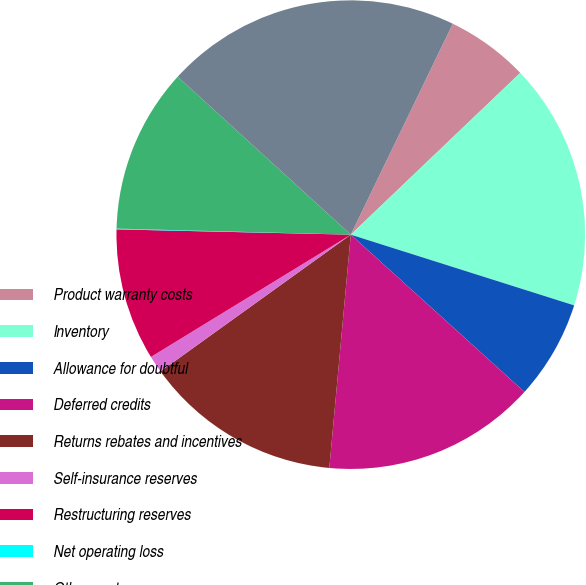<chart> <loc_0><loc_0><loc_500><loc_500><pie_chart><fcel>Product warranty costs<fcel>Inventory<fcel>Allowance for doubtful<fcel>Deferred credits<fcel>Returns rebates and incentives<fcel>Self-insurance reserves<fcel>Restructuring reserves<fcel>Net operating loss<fcel>Other - net<fcel>Current deferred income tax<nl><fcel>5.7%<fcel>17.01%<fcel>6.83%<fcel>14.75%<fcel>13.62%<fcel>1.18%<fcel>9.1%<fcel>0.05%<fcel>11.36%<fcel>20.4%<nl></chart> 